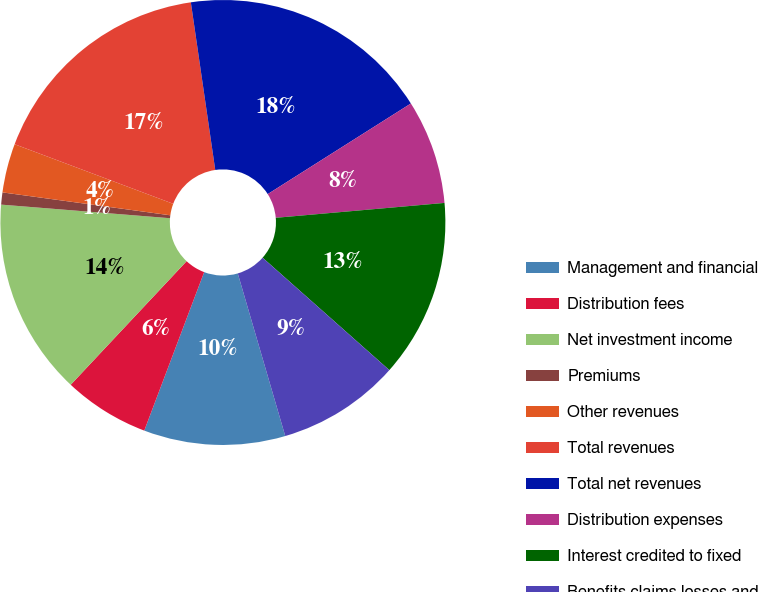<chart> <loc_0><loc_0><loc_500><loc_500><pie_chart><fcel>Management and financial<fcel>Distribution fees<fcel>Net investment income<fcel>Premiums<fcel>Other revenues<fcel>Total revenues<fcel>Total net revenues<fcel>Distribution expenses<fcel>Interest credited to fixed<fcel>Benefits claims losses and<nl><fcel>10.27%<fcel>6.24%<fcel>14.29%<fcel>0.88%<fcel>3.56%<fcel>16.98%<fcel>18.32%<fcel>7.58%<fcel>12.95%<fcel>8.93%<nl></chart> 